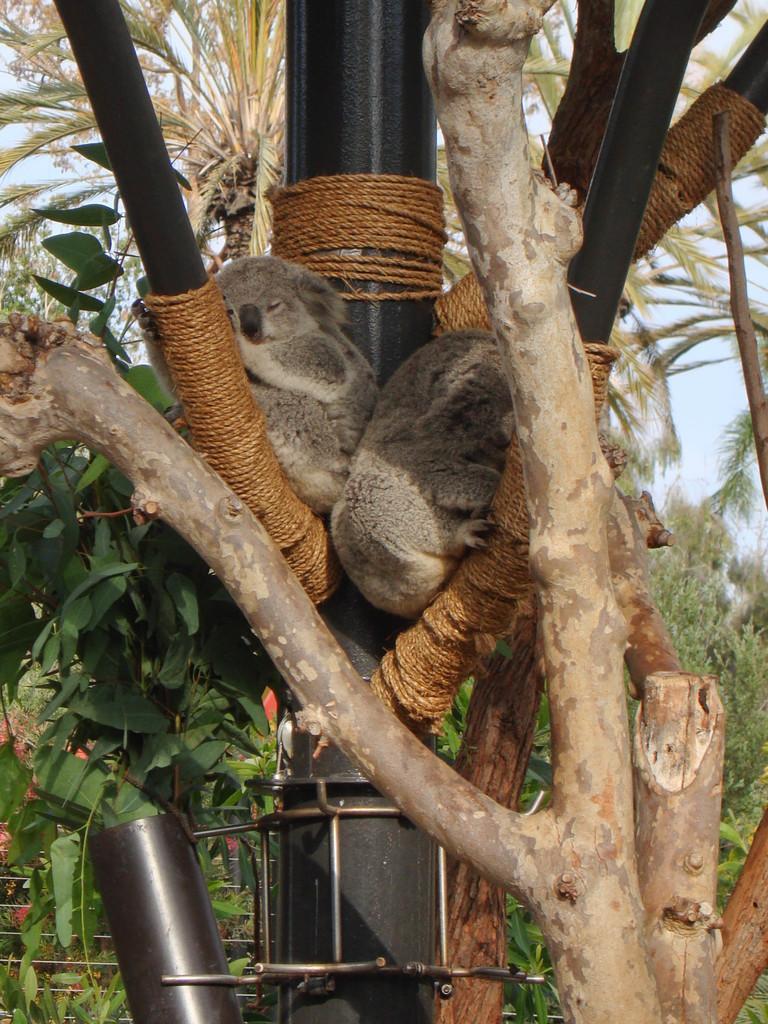Can you describe this image briefly? In this picture we can see pole and rope is pulled to the pole and animal sat on that pole and the background we can see tree and sky and in below we can see steel rod and fence. 